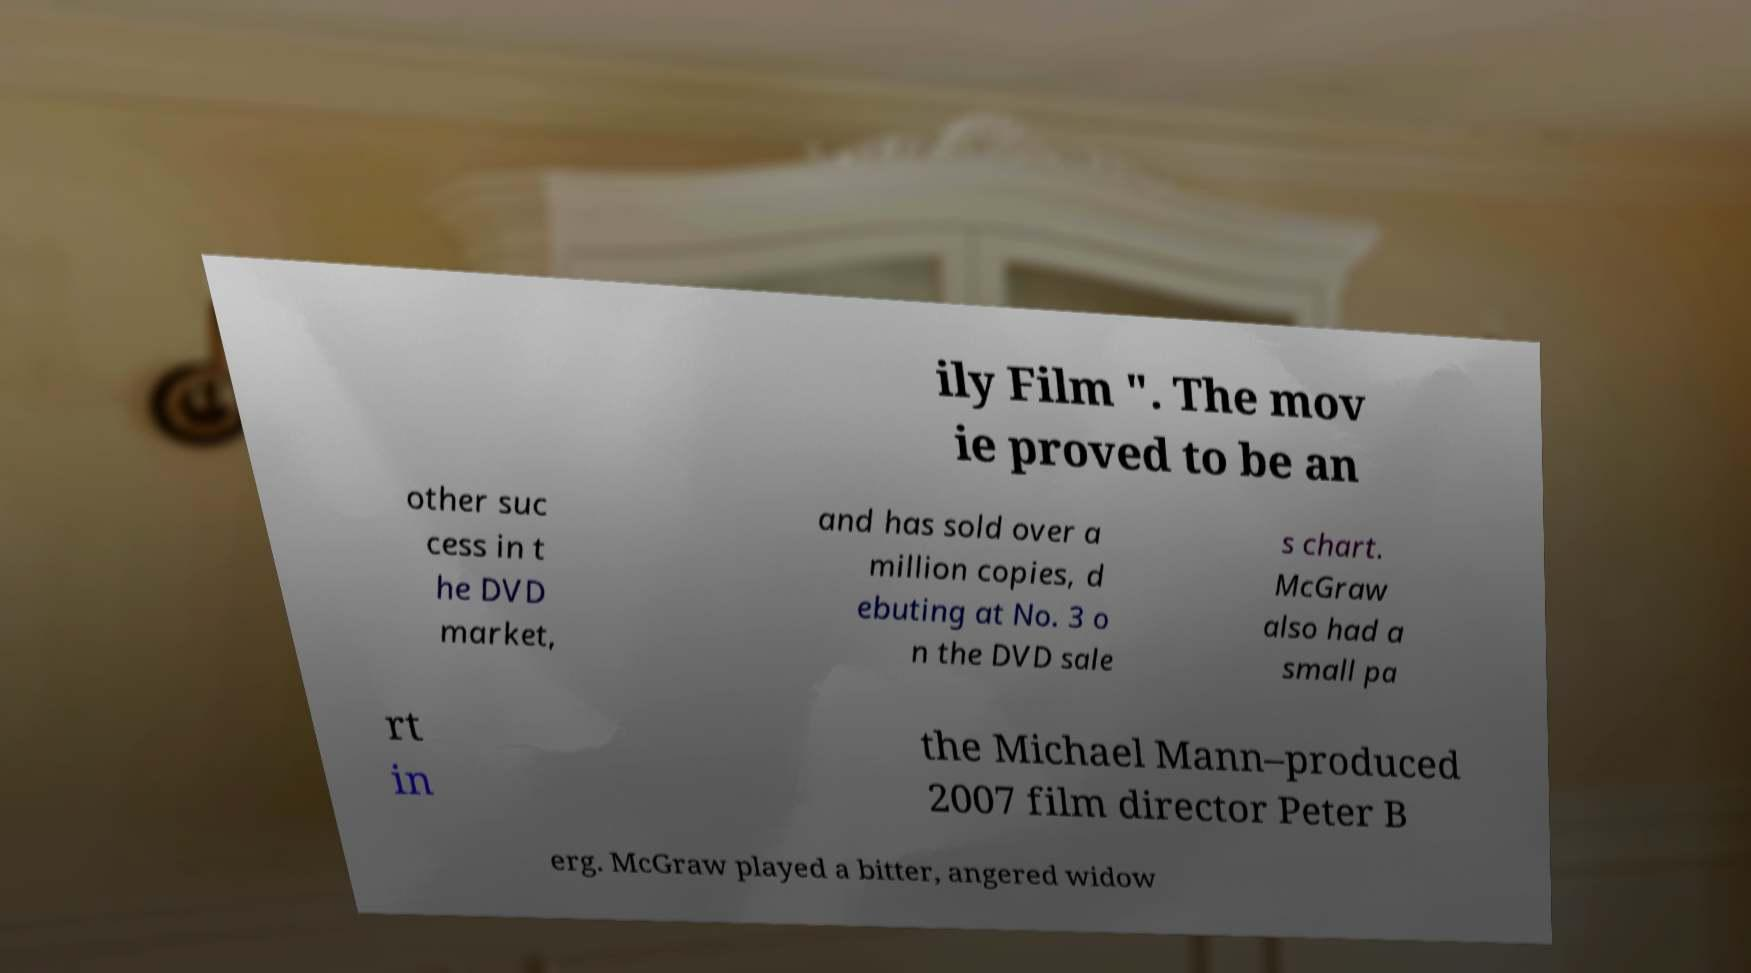For documentation purposes, I need the text within this image transcribed. Could you provide that? ily Film ". The mov ie proved to be an other suc cess in t he DVD market, and has sold over a million copies, d ebuting at No. 3 o n the DVD sale s chart. McGraw also had a small pa rt in the Michael Mann–produced 2007 film director Peter B erg. McGraw played a bitter, angered widow 